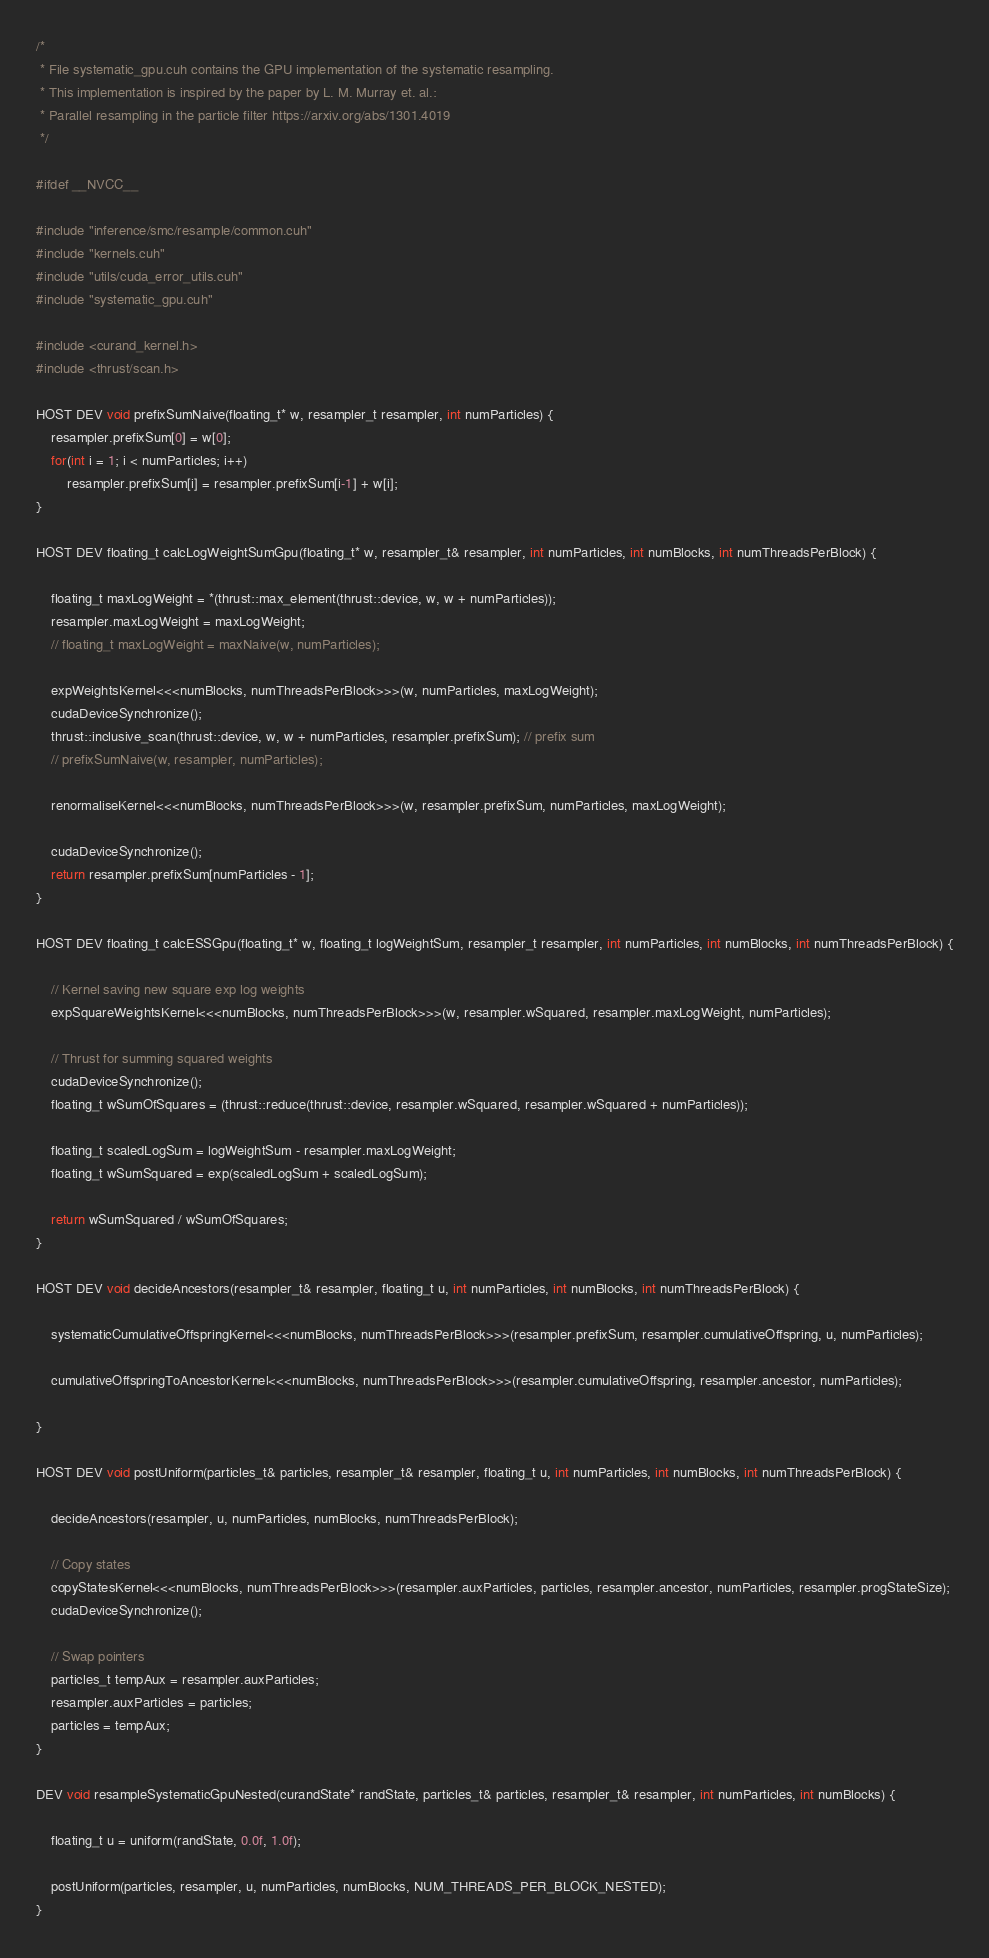<code> <loc_0><loc_0><loc_500><loc_500><_Cuda_>
/*
 * File systematic_gpu.cuh contains the GPU implementation of the systematic resampling. 
 * This implementation is inspired by the paper by L. M. Murray et. al.: 
 * Parallel resampling in the particle filter https://arxiv.org/abs/1301.4019
 */

#ifdef __NVCC__

#include "inference/smc/resample/common.cuh"
#include "kernels.cuh"
#include "utils/cuda_error_utils.cuh"
#include "systematic_gpu.cuh"

#include <curand_kernel.h>
#include <thrust/scan.h>

HOST DEV void prefixSumNaive(floating_t* w, resampler_t resampler, int numParticles) {
    resampler.prefixSum[0] = w[0];
    for(int i = 1; i < numParticles; i++)
        resampler.prefixSum[i] = resampler.prefixSum[i-1] + w[i];
}

HOST DEV floating_t calcLogWeightSumGpu(floating_t* w, resampler_t& resampler, int numParticles, int numBlocks, int numThreadsPerBlock) {

    floating_t maxLogWeight = *(thrust::max_element(thrust::device, w, w + numParticles));
    resampler.maxLogWeight = maxLogWeight;
    // floating_t maxLogWeight = maxNaive(w, numParticles);
    
    expWeightsKernel<<<numBlocks, numThreadsPerBlock>>>(w, numParticles, maxLogWeight);
    cudaDeviceSynchronize();
    thrust::inclusive_scan(thrust::device, w, w + numParticles, resampler.prefixSum); // prefix sum
    // prefixSumNaive(w, resampler, numParticles);

    renormaliseKernel<<<numBlocks, numThreadsPerBlock>>>(w, resampler.prefixSum, numParticles, maxLogWeight);
    
    cudaDeviceSynchronize();
    return resampler.prefixSum[numParticles - 1];
}

HOST DEV floating_t calcESSGpu(floating_t* w, floating_t logWeightSum, resampler_t resampler, int numParticles, int numBlocks, int numThreadsPerBlock) {

    // Kernel saving new square exp log weights
    expSquareWeightsKernel<<<numBlocks, numThreadsPerBlock>>>(w, resampler.wSquared, resampler.maxLogWeight, numParticles);

    // Thrust for summing squared weights
    cudaDeviceSynchronize();
    floating_t wSumOfSquares = (thrust::reduce(thrust::device, resampler.wSquared, resampler.wSquared + numParticles));

    floating_t scaledLogSum = logWeightSum - resampler.maxLogWeight;
    floating_t wSumSquared = exp(scaledLogSum + scaledLogSum);

    return wSumSquared / wSumOfSquares;
}

HOST DEV void decideAncestors(resampler_t& resampler, floating_t u, int numParticles, int numBlocks, int numThreadsPerBlock) {

    systematicCumulativeOffspringKernel<<<numBlocks, numThreadsPerBlock>>>(resampler.prefixSum, resampler.cumulativeOffspring, u, numParticles);

    cumulativeOffspringToAncestorKernel<<<numBlocks, numThreadsPerBlock>>>(resampler.cumulativeOffspring, resampler.ancestor, numParticles);

}

HOST DEV void postUniform(particles_t& particles, resampler_t& resampler, floating_t u, int numParticles, int numBlocks, int numThreadsPerBlock) {

    decideAncestors(resampler, u, numParticles, numBlocks, numThreadsPerBlock);

    // Copy states
    copyStatesKernel<<<numBlocks, numThreadsPerBlock>>>(resampler.auxParticles, particles, resampler.ancestor, numParticles, resampler.progStateSize);
    cudaDeviceSynchronize();

    // Swap pointers
    particles_t tempAux = resampler.auxParticles;
    resampler.auxParticles = particles;
    particles = tempAux;
}

DEV void resampleSystematicGpuNested(curandState* randState, particles_t& particles, resampler_t& resampler, int numParticles, int numBlocks) {
    
    floating_t u = uniform(randState, 0.0f, 1.0f);
    
    postUniform(particles, resampler, u, numParticles, numBlocks, NUM_THREADS_PER_BLOCK_NESTED);
}
</code> 